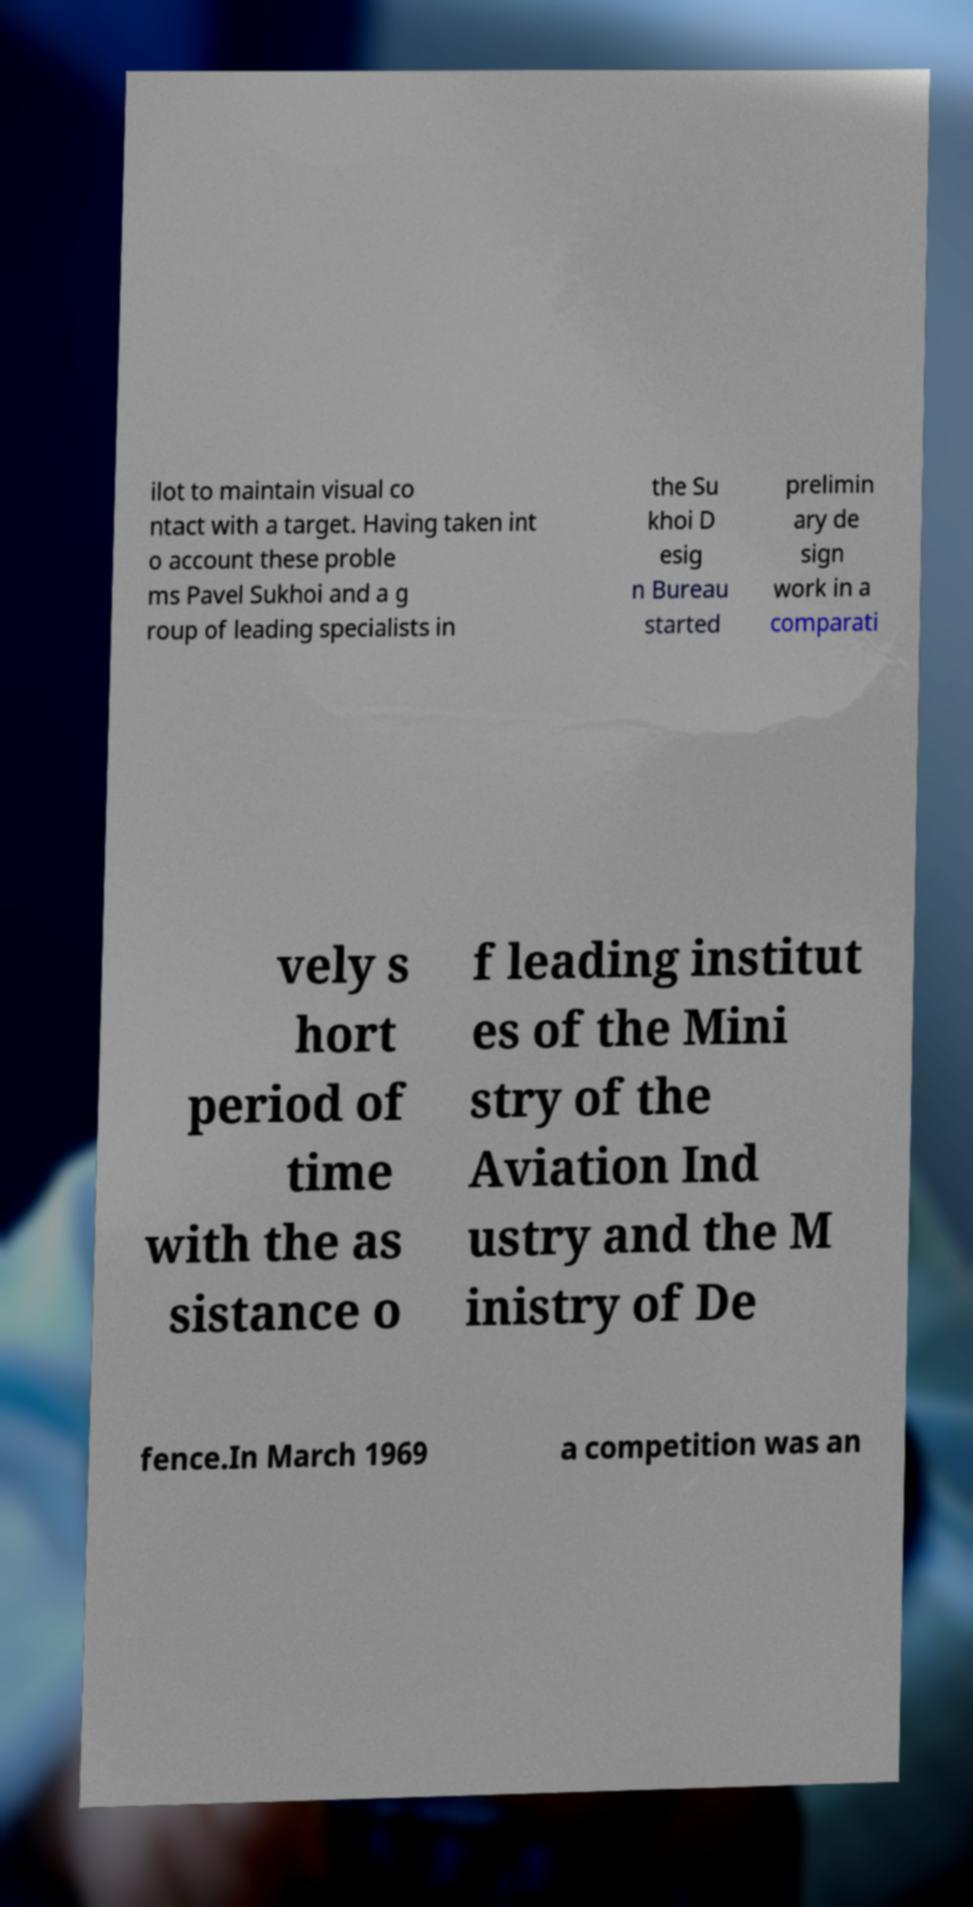Can you read and provide the text displayed in the image?This photo seems to have some interesting text. Can you extract and type it out for me? ilot to maintain visual co ntact with a target. Having taken int o account these proble ms Pavel Sukhoi and a g roup of leading specialists in the Su khoi D esig n Bureau started prelimin ary de sign work in a comparati vely s hort period of time with the as sistance o f leading institut es of the Mini stry of the Aviation Ind ustry and the M inistry of De fence.In March 1969 a competition was an 